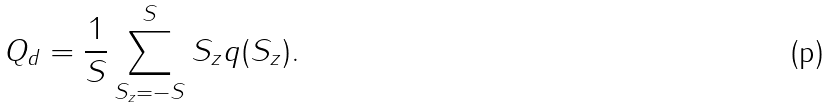<formula> <loc_0><loc_0><loc_500><loc_500>Q _ { d } = \frac { 1 } { S } \sum _ { S _ { z } = - S } ^ { S } S _ { z } q ( S _ { z } ) .</formula> 